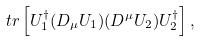Convert formula to latex. <formula><loc_0><loc_0><loc_500><loc_500>\ t r \left [ U _ { 1 } ^ { \dagger } ( D _ { \mu } U _ { 1 } ) ( D ^ { \mu } U _ { 2 } ) U _ { 2 } ^ { \dagger } \right ] ,</formula> 